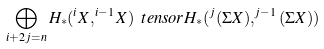<formula> <loc_0><loc_0><loc_500><loc_500>\bigoplus _ { i + 2 j = n } H _ { * } ( ^ { i } X , ^ { i - 1 } X ) \ t e n s o r H _ { * } ( ^ { j } ( \Sigma X ) , ^ { j - 1 } ( \Sigma X ) )</formula> 